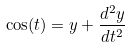Convert formula to latex. <formula><loc_0><loc_0><loc_500><loc_500>\cos ( t ) = y + \frac { d ^ { 2 } y } { d t ^ { 2 } }</formula> 